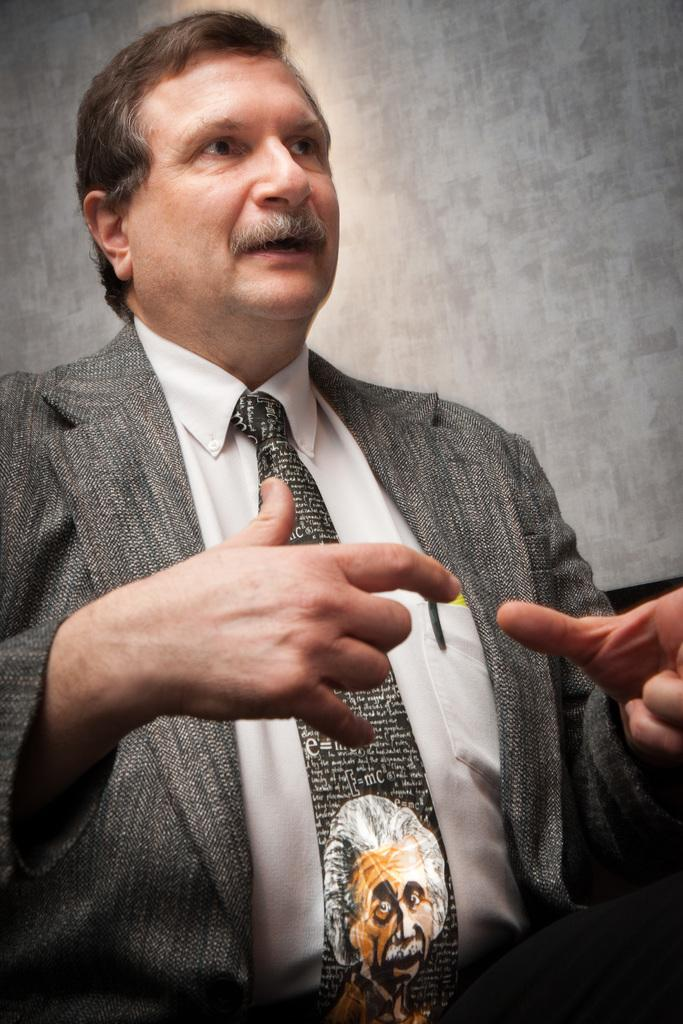What is the main subject of the picture? The main subject of the picture is a man. What is the man doing in the picture? The man appears to be speaking in the picture. Can you describe the man's attire? The man is wearing a suit and a tie. What type of fowl can be seen perched on the man's shoulder in the image? There is no fowl present on the man's shoulder in the image. What type of lace is visible on the man's clothing in the image? There is no lace visible on the man's clothing in the image. 